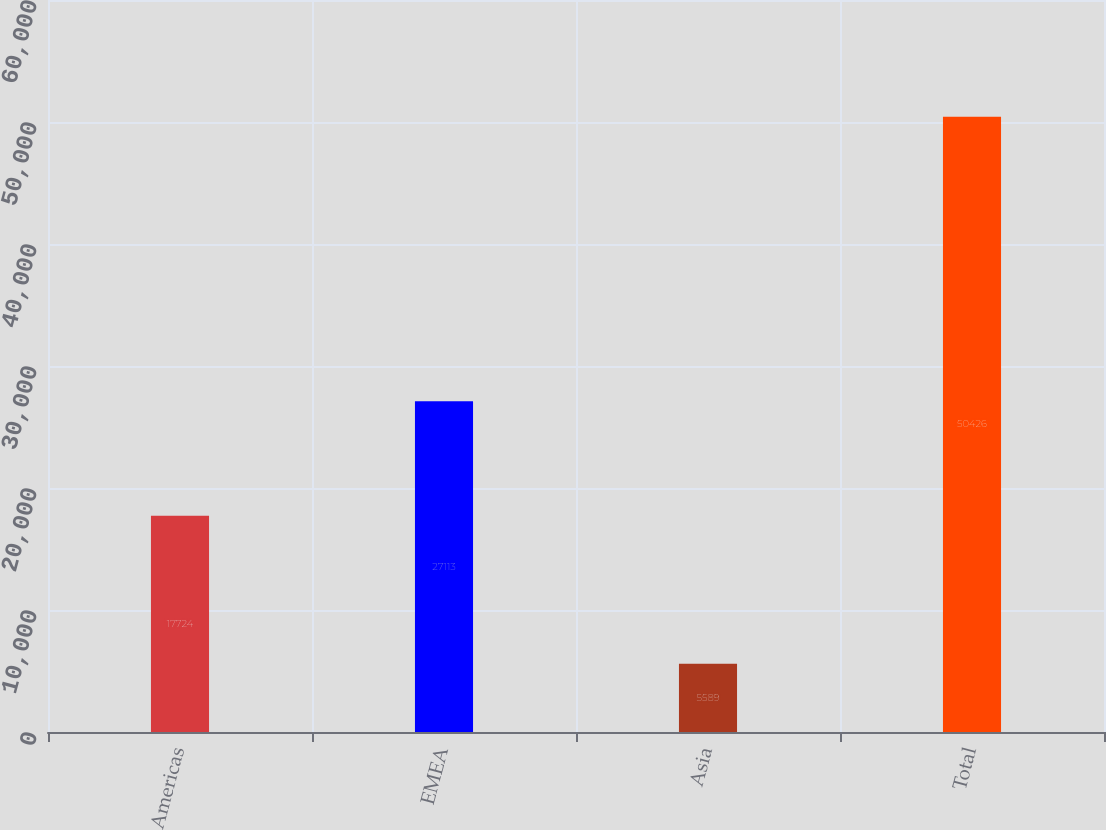<chart> <loc_0><loc_0><loc_500><loc_500><bar_chart><fcel>Americas<fcel>EMEA<fcel>Asia<fcel>Total<nl><fcel>17724<fcel>27113<fcel>5589<fcel>50426<nl></chart> 